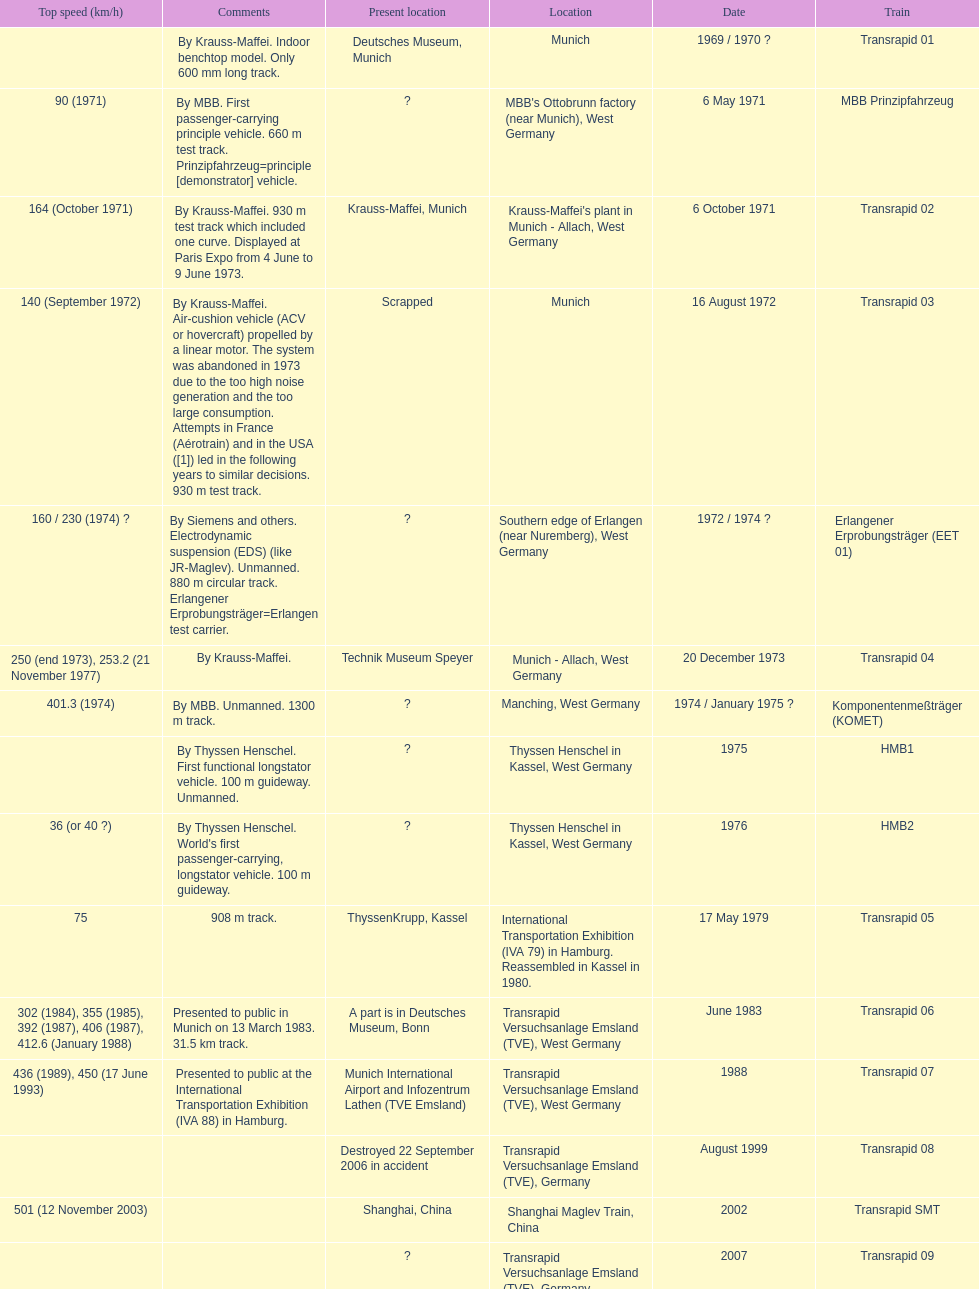How many trains listed have the same speed as the hmb2? 0. 